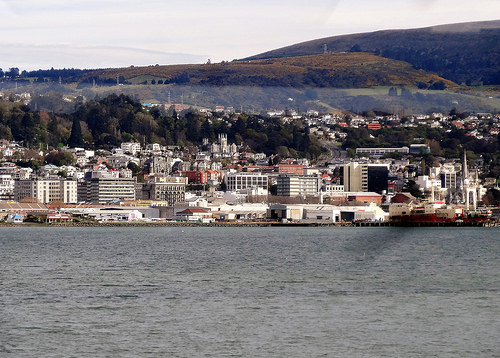<image>
Is there a water behind the buildings? No. The water is not behind the buildings. From this viewpoint, the water appears to be positioned elsewhere in the scene. 